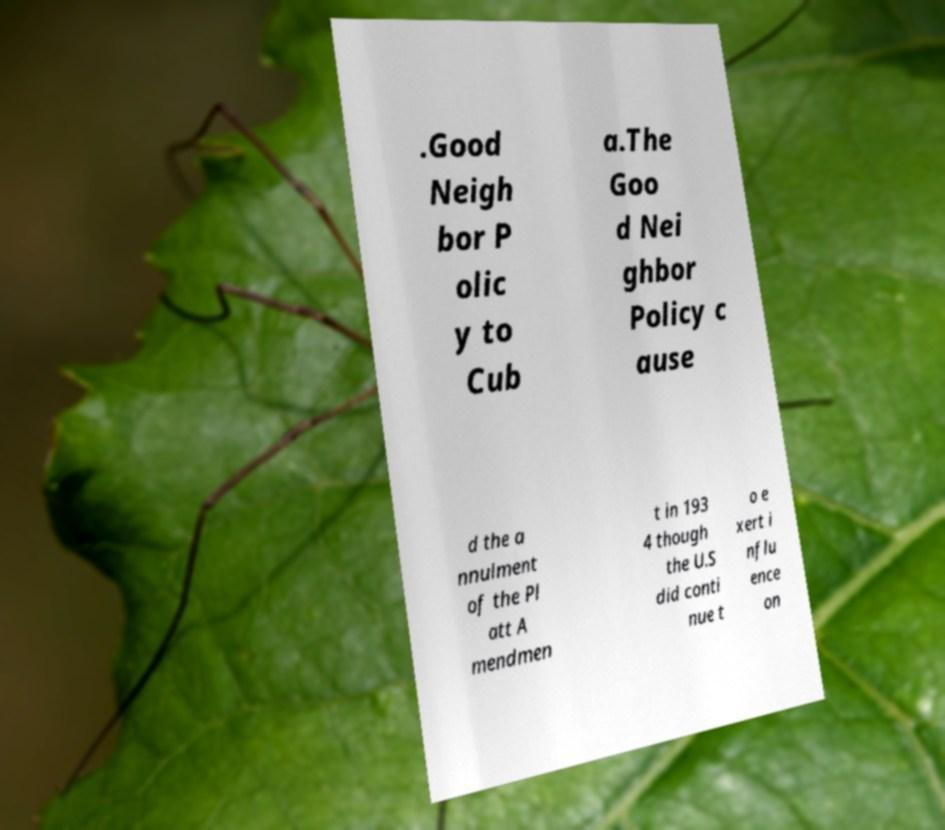Can you read and provide the text displayed in the image?This photo seems to have some interesting text. Can you extract and type it out for me? .Good Neigh bor P olic y to Cub a.The Goo d Nei ghbor Policy c ause d the a nnulment of the Pl att A mendmen t in 193 4 though the U.S did conti nue t o e xert i nflu ence on 